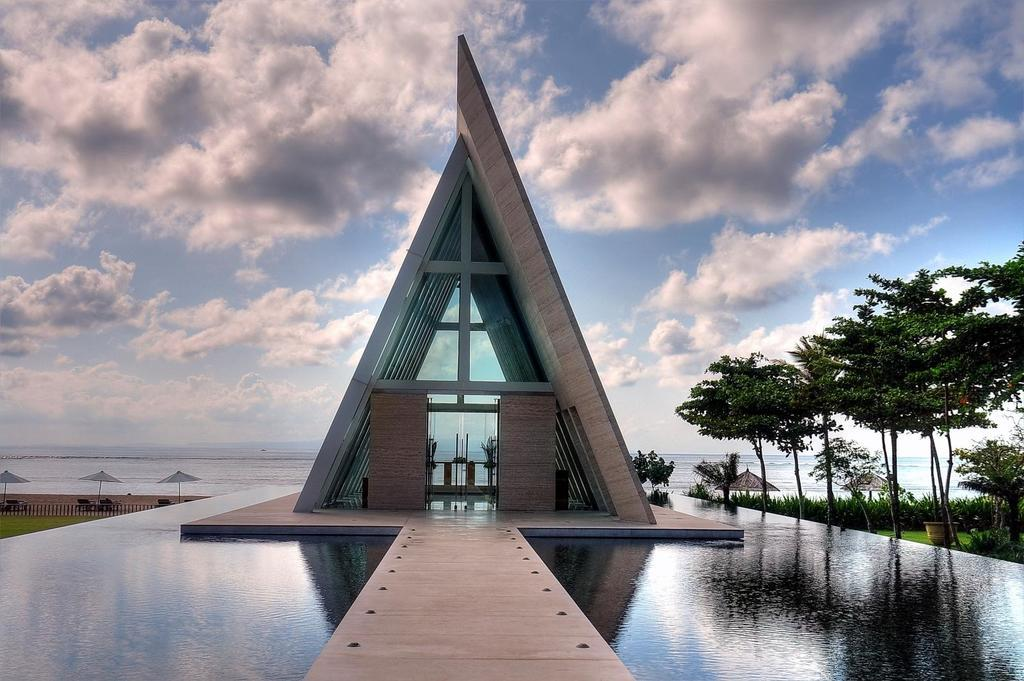What type of surface can be seen in the image? There is a path in the image. What natural element is visible in the image? There is water visible in the image. What man-made structure is present in the image? There is a building in the image. What type of vegetation is present in the image? There are trees in the image. What objects are present in the image for protection from the rain? There are umbrellas in the image. What type of barrier is present in the image? There is a fence in the image. What type of living organisms can be seen in the image? There are plants in the image. What else can be seen in the image? There are some objects in the image. What is visible in the background of the image? The sky is visible in the background of the image. What can be seen in the sky? There are clouds in the sky. What type of bread can be seen in the image? There is no bread present in the image. How many deer are visible in the image? There are no deer present in the image. 